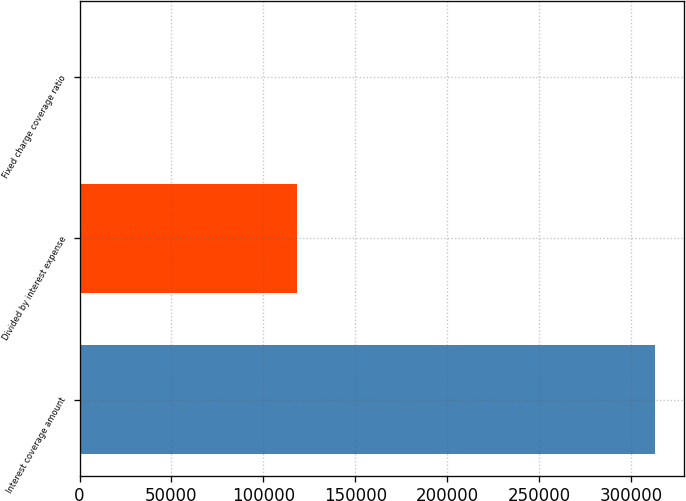<chart> <loc_0><loc_0><loc_500><loc_500><bar_chart><fcel>Interest coverage amount<fcel>Divided by interest expense<fcel>Fixed charge coverage ratio<nl><fcel>313313<fcel>118047<fcel>2.7<nl></chart> 